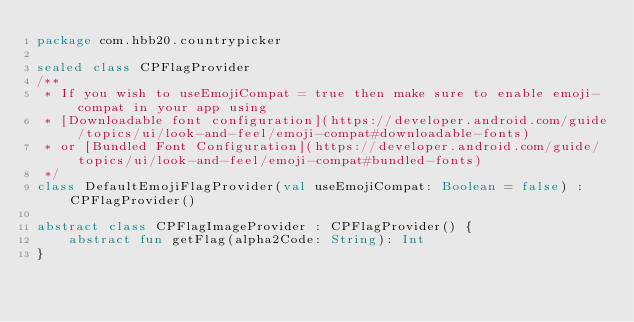Convert code to text. <code><loc_0><loc_0><loc_500><loc_500><_Kotlin_>package com.hbb20.countrypicker

sealed class CPFlagProvider
/**
 * If you wish to useEmojiCompat = true then make sure to enable emoji-compat in your app using
 * [Downloadable font configuration](https://developer.android.com/guide/topics/ui/look-and-feel/emoji-compat#downloadable-fonts)
 * or [Bundled Font Configuration](https://developer.android.com/guide/topics/ui/look-and-feel/emoji-compat#bundled-fonts)
 */
class DefaultEmojiFlagProvider(val useEmojiCompat: Boolean = false) : CPFlagProvider()

abstract class CPFlagImageProvider : CPFlagProvider() {
    abstract fun getFlag(alpha2Code: String): Int
}
</code> 